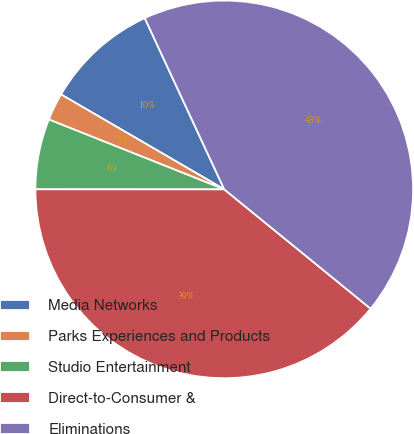Convert chart to OTSL. <chart><loc_0><loc_0><loc_500><loc_500><pie_chart><fcel>Media Networks<fcel>Parks Experiences and Products<fcel>Studio Entertainment<fcel>Direct-to-Consumer &<fcel>Eliminations<nl><fcel>9.7%<fcel>2.35%<fcel>6.03%<fcel>39.12%<fcel>42.8%<nl></chart> 